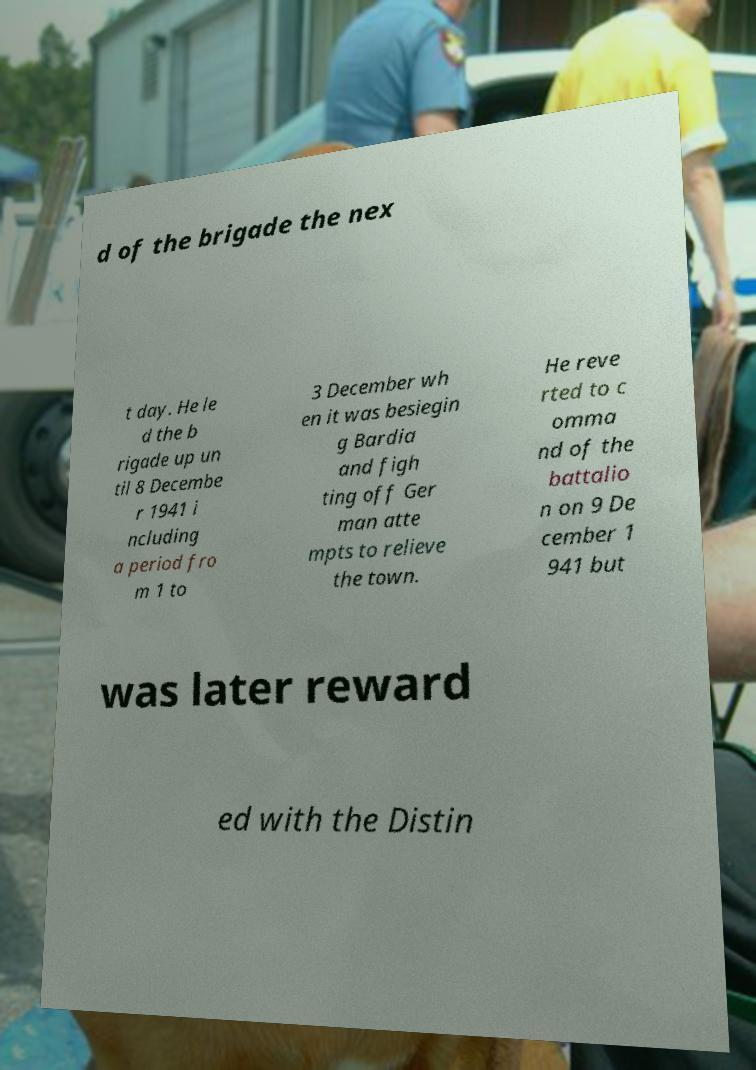Can you accurately transcribe the text from the provided image for me? d of the brigade the nex t day. He le d the b rigade up un til 8 Decembe r 1941 i ncluding a period fro m 1 to 3 December wh en it was besiegin g Bardia and figh ting off Ger man atte mpts to relieve the town. He reve rted to c omma nd of the battalio n on 9 De cember 1 941 but was later reward ed with the Distin 